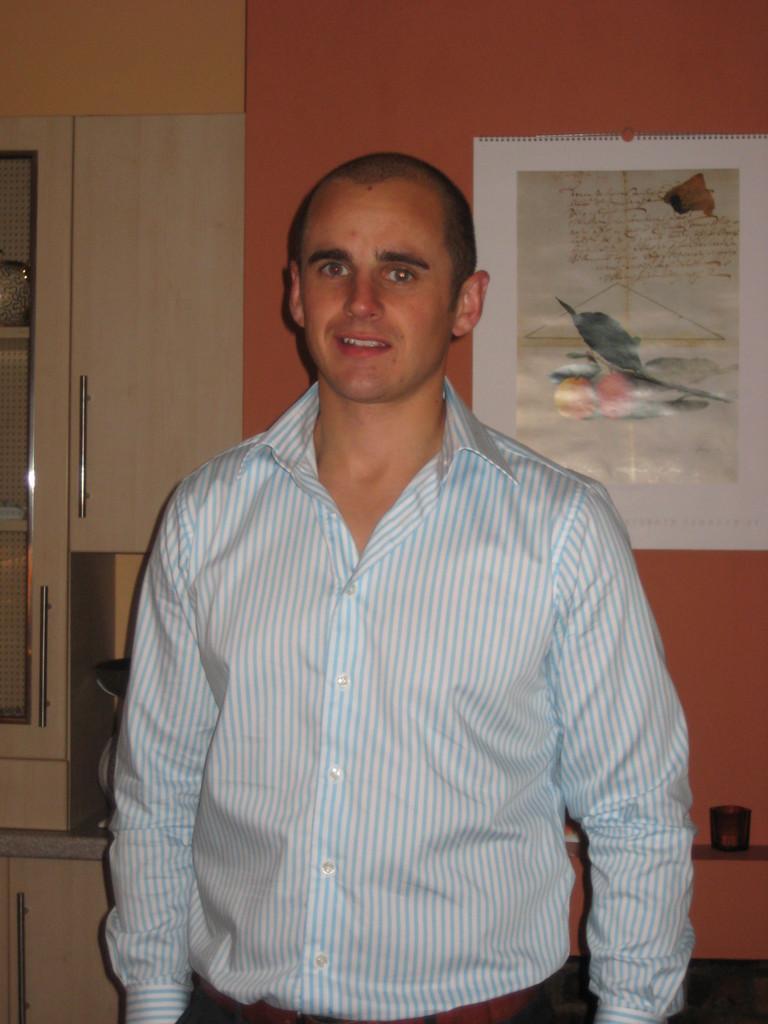Describe this image in one or two sentences. In the picture I can see a man is standing and smiling. The man is wearing a shirt. In the background I can see a poster attached to the wall and some other objects. 